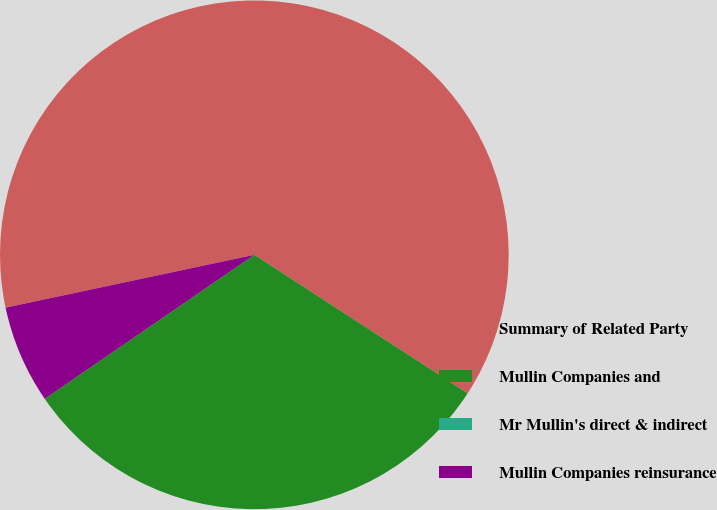Convert chart to OTSL. <chart><loc_0><loc_0><loc_500><loc_500><pie_chart><fcel>Summary of Related Party<fcel>Mullin Companies and<fcel>Mr Mullin's direct & indirect<fcel>Mullin Companies reinsurance<nl><fcel>62.5%<fcel>31.25%<fcel>0.0%<fcel>6.25%<nl></chart> 